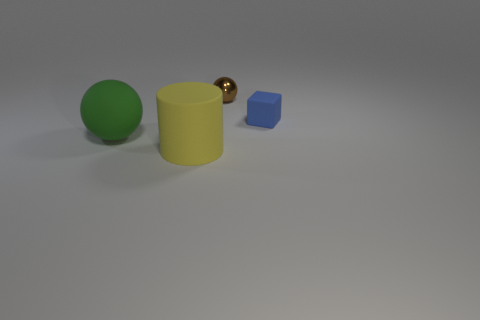Subtract all cylinders. How many objects are left? 3 Subtract all green balls. How many balls are left? 1 Add 4 big balls. How many big balls are left? 5 Add 1 red objects. How many red objects exist? 1 Add 4 big purple things. How many objects exist? 8 Subtract 1 yellow cylinders. How many objects are left? 3 Subtract 1 cubes. How many cubes are left? 0 Subtract all purple spheres. Subtract all yellow cylinders. How many spheres are left? 2 Subtract all brown cubes. How many blue cylinders are left? 0 Subtract all big yellow things. Subtract all brown matte objects. How many objects are left? 3 